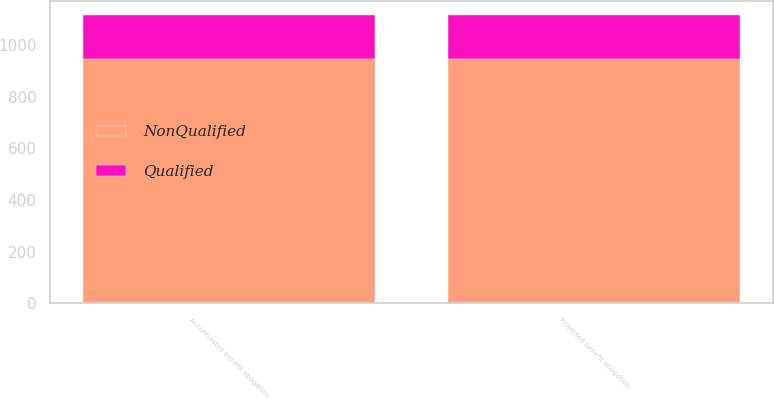Convert chart. <chart><loc_0><loc_0><loc_500><loc_500><stacked_bar_chart><ecel><fcel>Projected benefit obligation<fcel>Accumulated benefit obligation<nl><fcel>NonQualified<fcel>945<fcel>945<nl><fcel>Qualified<fcel>170<fcel>170<nl></chart> 